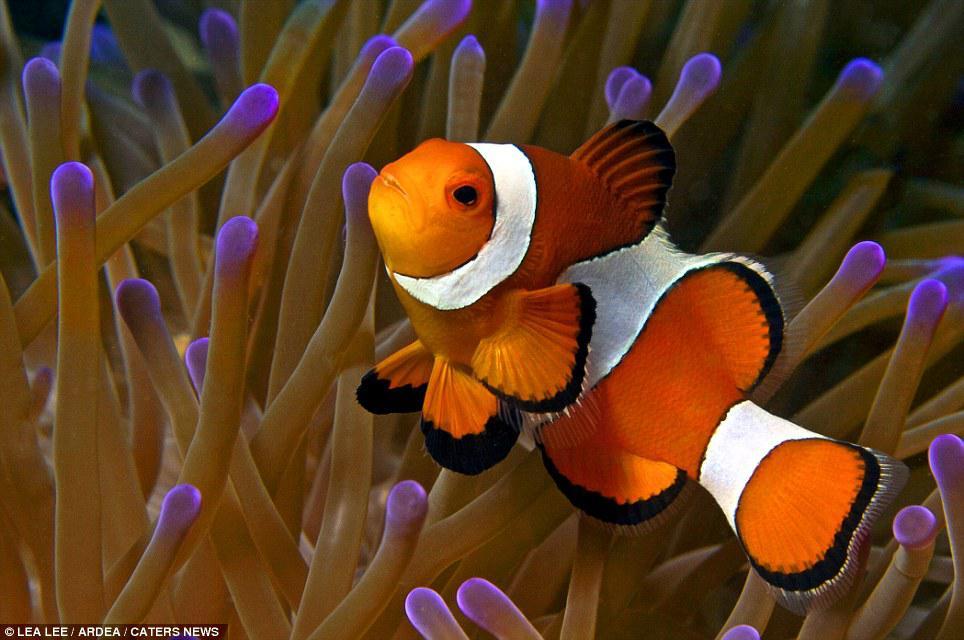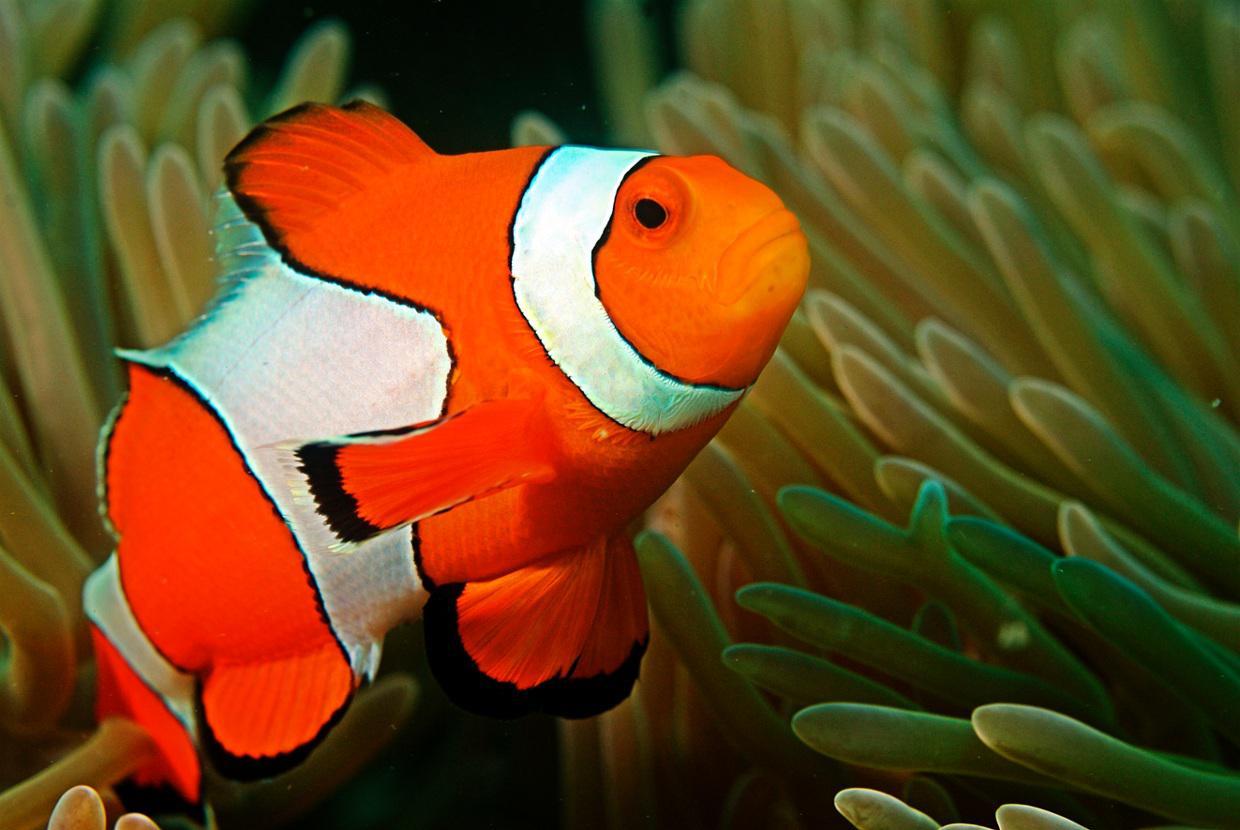The first image is the image on the left, the second image is the image on the right. Considering the images on both sides, is "There are two fish" valid? Answer yes or no. Yes. 